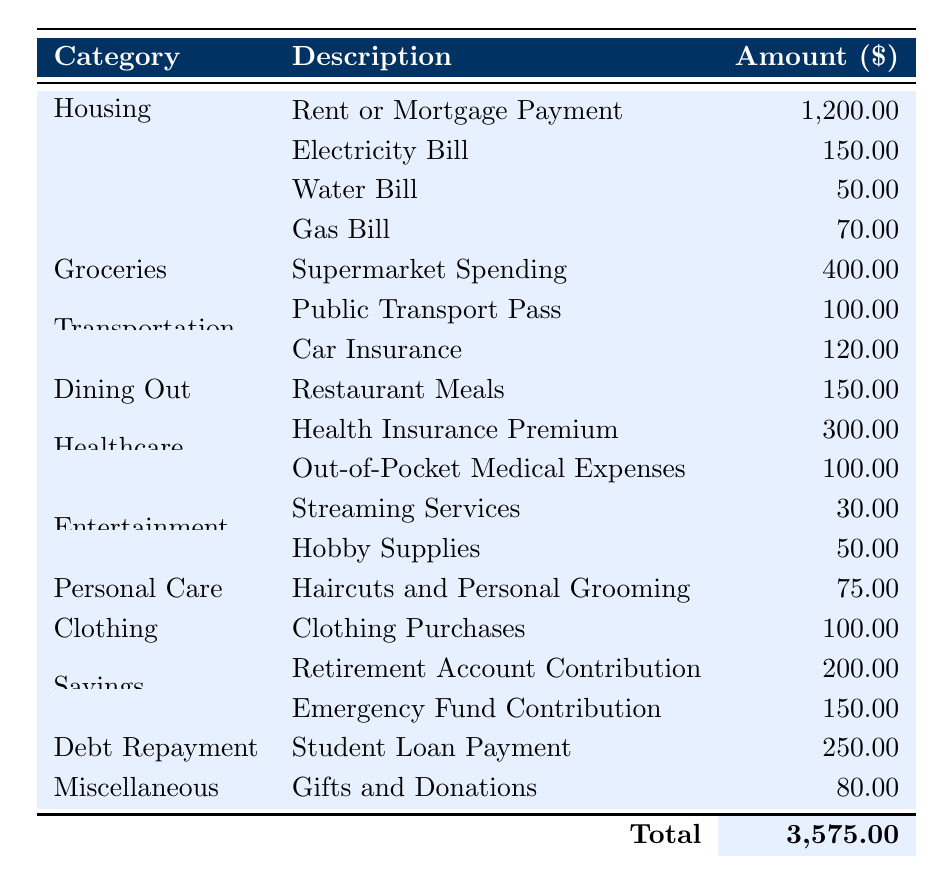What is the total amount spent on Utilities? To find the total amount spent on Utilities, I will sum the amounts for the three utility bills: Electricity Bill ($150) + Water Bill ($50) + Gas Bill ($70) = $270.
Answer: 270 How much is spent on Housing compared to Transportation? The amount spent on Housing is $1200, and the total amount spent on Transportation is Public Transport Pass ($100) + Car Insurance ($120) = $220. The difference is $1200 - $220 = $980.
Answer: 980 What is the total spending on Savings? To find the total Savings amount, I will sum the contributions: Retirement Account Contribution ($200) + Emergency Fund Contribution ($150) = $350.
Answer: 350 Is the amount spent on Dining Out greater than that spent on Entertainment? The amount for Dining Out is $150, while the total for Entertainment is Streaming Services ($30) + Hobby Supplies ($50) = $80. Since $150 > $80, the statement is true.
Answer: Yes What is the average monthly expense across all categories? To find the average, I will first sum all expenses: $1200 + $270 + $400 + $220 + $150 + $400 + $75 + $100 + $350 + $250 + $80 = $3575. Then, I divide this total by the number of categories (16), resulting in $3575 / 16 = $223.44.
Answer: 223.44 Which category has the highest expense, and how much is it? Considering the amounts in the table, Housing has the highest expense at $1200.
Answer: Housing, 1200 Would reducing the Dining Out budget by $50 change its ranking among expense categories? The current amount for Dining Out is $150; if reduced by $50, it would become $100. After the reduction, compare with the next highest categories: Dining Out ($100), Entertainment (total $80), and Personal Care ($75) still positions Dining Out higher. Therefore, it does not change its ranking.
Answer: No What is the total amount spent on Healthcare? The total spent on Healthcare includes the Health Insurance Premium ($300) and Out-of-Pocket Medical Expenses ($100), resulting in $300 + $100 = $400.
Answer: 400 How much more is spent on Debt Repayment compared to Entertainment? The amount spent on Debt Repayment is $250, while Entertainment totals $80. The difference in spending is $250 - $80 = $170.
Answer: 170 If the Miscellaneous budget were completely eliminated, what would the new total monthly expense be? The current total monthly expense is $3575; eliminating the Miscellaneous category at $80 would lead to $3575 - $80 = $3495.
Answer: 3495 